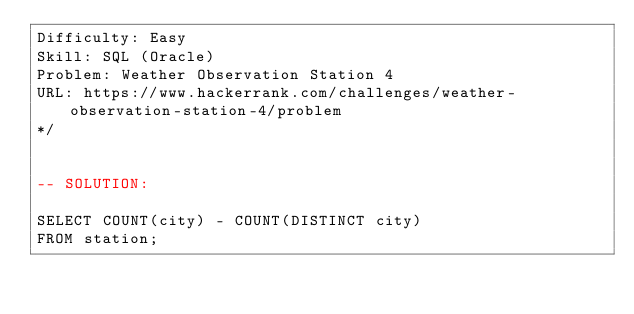Convert code to text. <code><loc_0><loc_0><loc_500><loc_500><_SQL_>Difficulty: Easy
Skill: SQL (Oracle)
Problem: Weather Observation Station 4
URL: https://www.hackerrank.com/challenges/weather-observation-station-4/problem
*/


-- SOLUTION:

SELECT COUNT(city) - COUNT(DISTINCT city) 
FROM station;</code> 